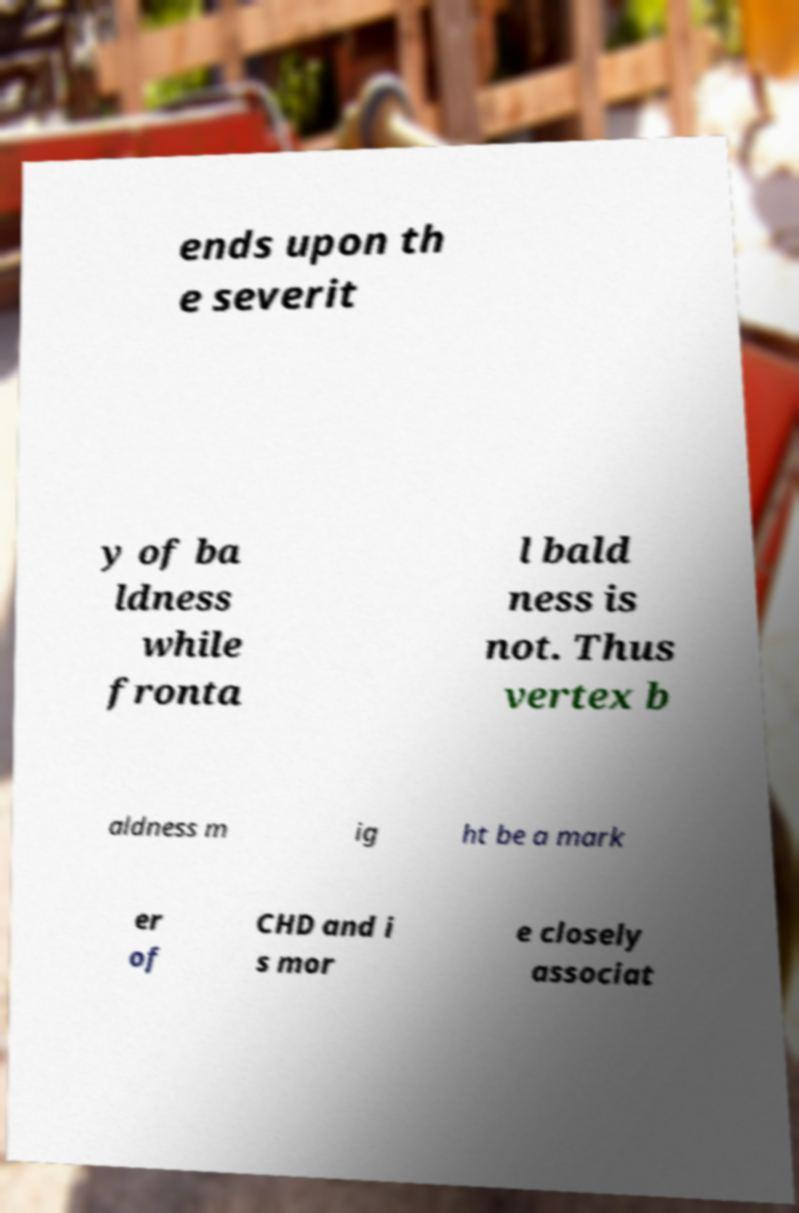Can you accurately transcribe the text from the provided image for me? ends upon th e severit y of ba ldness while fronta l bald ness is not. Thus vertex b aldness m ig ht be a mark er of CHD and i s mor e closely associat 